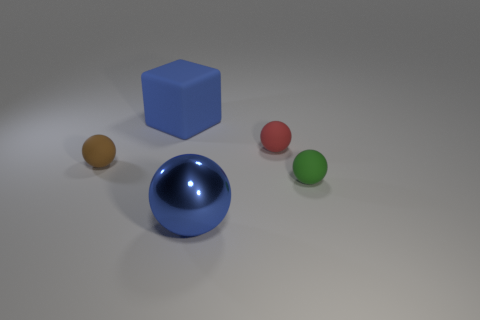Does the sphere that is on the left side of the large blue block have the same material as the blue cube? Yes, the sphere on the left side of the large blue cube indeed shares the same glossy and reflective material characteristics as the blue cube itself, signifying they are likely made of similar substances. 